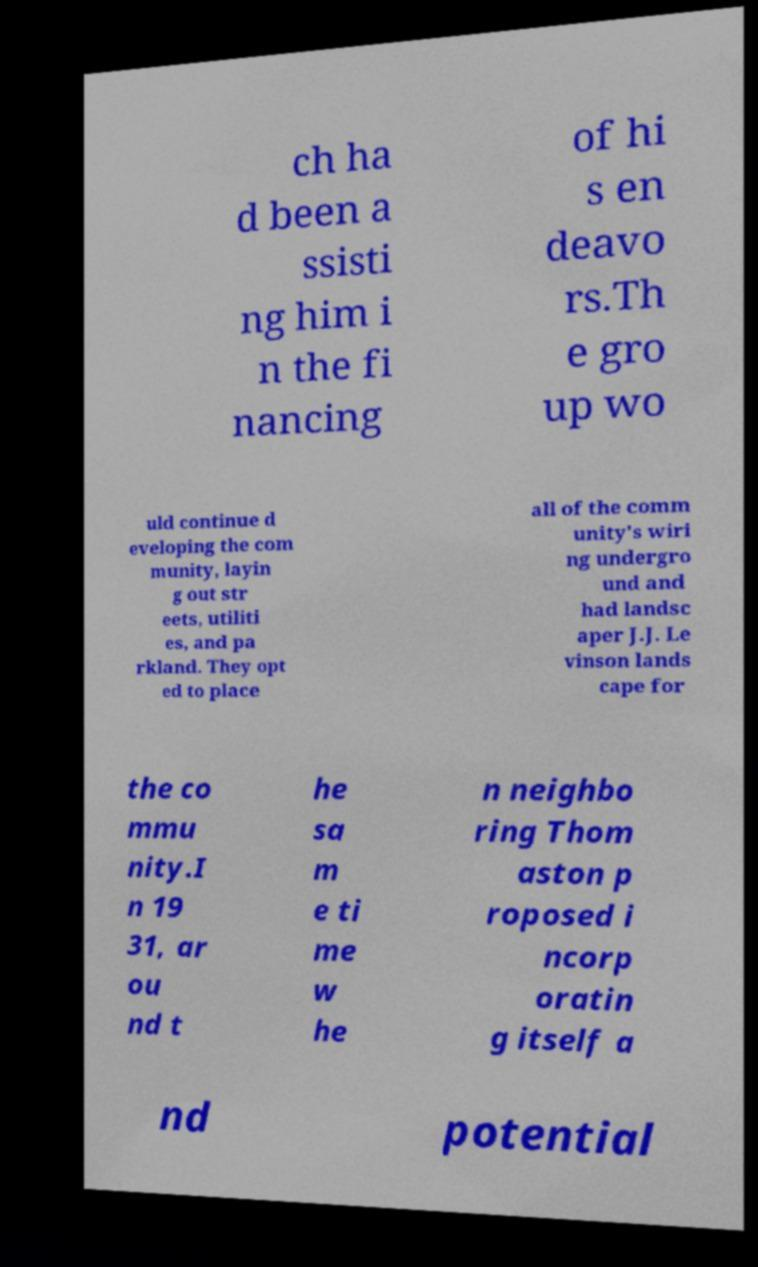What messages or text are displayed in this image? I need them in a readable, typed format. ch ha d been a ssisti ng him i n the fi nancing of hi s en deavo rs.Th e gro up wo uld continue d eveloping the com munity, layin g out str eets, utiliti es, and pa rkland. They opt ed to place all of the comm unity's wiri ng undergro und and had landsc aper J.J. Le vinson lands cape for the co mmu nity.I n 19 31, ar ou nd t he sa m e ti me w he n neighbo ring Thom aston p roposed i ncorp oratin g itself a nd potential 